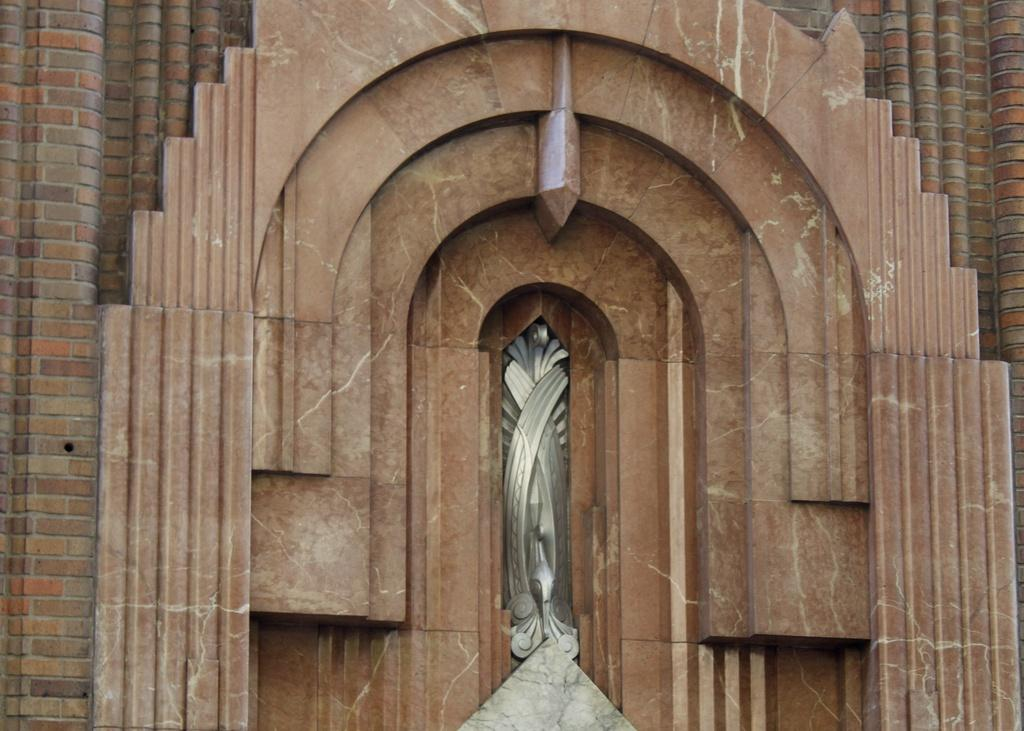What type of structure is present in the image? There is an arch in the image. What type of artwork can be seen in the image? There is some sculpture in the image. What is the material of the walls on both sides of the image? There is a brick wall on the left side and a brick wall on the right side of the image. How many ears of corn are growing on the left brick wall in the image? There are no ears of corn present on the brick walls in the image. What type of zipper can be seen on the sculpture in the image? There is no zipper present on the sculpture in the image. 